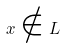Convert formula to latex. <formula><loc_0><loc_0><loc_500><loc_500>x \notin L</formula> 